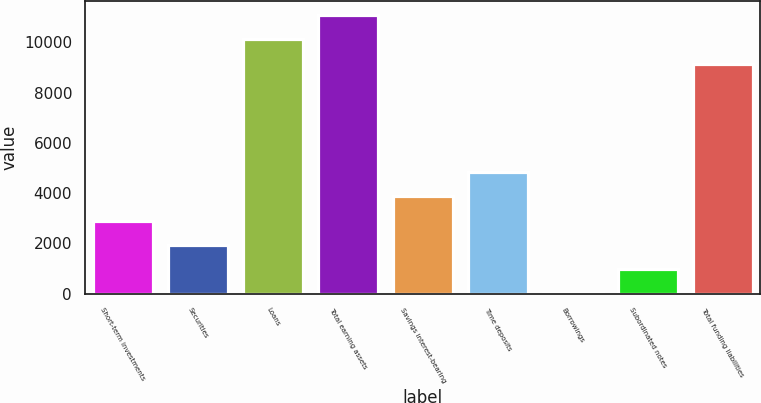Convert chart to OTSL. <chart><loc_0><loc_0><loc_500><loc_500><bar_chart><fcel>Short-term investments<fcel>Securities<fcel>Loans<fcel>Total earning assets<fcel>Savings interest-bearing<fcel>Time deposits<fcel>Borrowings<fcel>Subordinated notes<fcel>Total funding liabilities<nl><fcel>2905.01<fcel>1938.04<fcel>10119<fcel>11085.9<fcel>3871.98<fcel>4838.95<fcel>4.1<fcel>971.07<fcel>9152<nl></chart> 